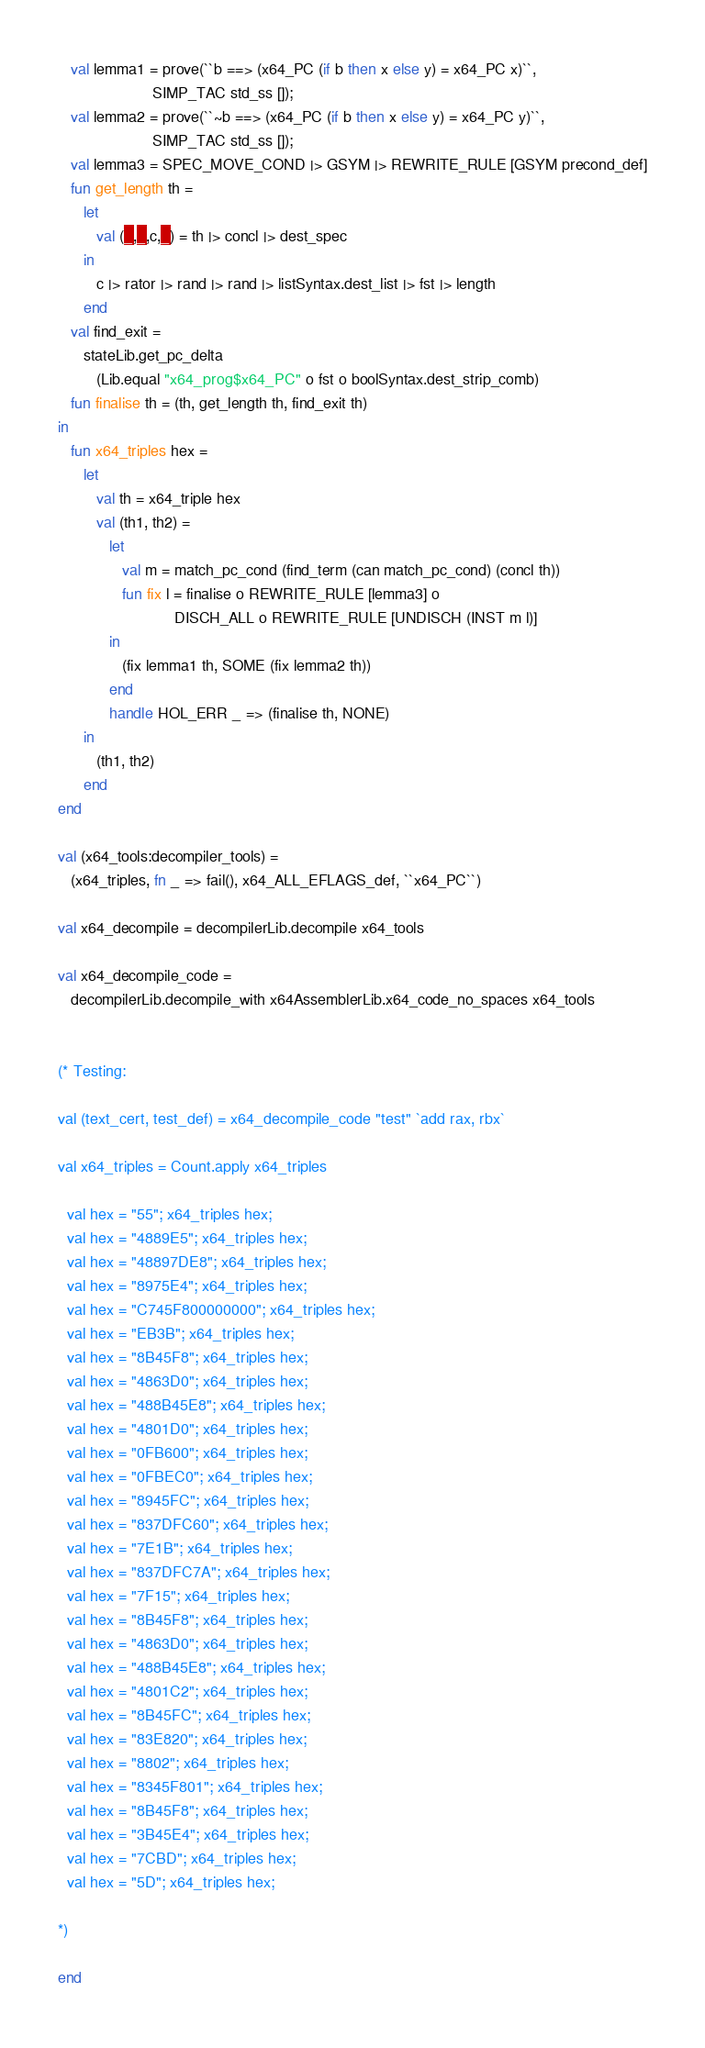Convert code to text. <code><loc_0><loc_0><loc_500><loc_500><_SML_>   val lemma1 = prove(``b ==> (x64_PC (if b then x else y) = x64_PC x)``,
                      SIMP_TAC std_ss []);
   val lemma2 = prove(``~b ==> (x64_PC (if b then x else y) = x64_PC y)``,
                      SIMP_TAC std_ss []);
   val lemma3 = SPEC_MOVE_COND |> GSYM |> REWRITE_RULE [GSYM precond_def]
   fun get_length th =
      let
         val (_,_,c,_) = th |> concl |> dest_spec
      in
         c |> rator |> rand |> rand |> listSyntax.dest_list |> fst |> length
      end
   val find_exit =
      stateLib.get_pc_delta
         (Lib.equal "x64_prog$x64_PC" o fst o boolSyntax.dest_strip_comb)
   fun finalise th = (th, get_length th, find_exit th)
in
   fun x64_triples hex =
      let
         val th = x64_triple hex
         val (th1, th2) =
            let
               val m = match_pc_cond (find_term (can match_pc_cond) (concl th))
               fun fix l = finalise o REWRITE_RULE [lemma3] o
                           DISCH_ALL o REWRITE_RULE [UNDISCH (INST m l)]
            in
               (fix lemma1 th, SOME (fix lemma2 th))
            end
            handle HOL_ERR _ => (finalise th, NONE)
      in
         (th1, th2)
      end
end

val (x64_tools:decompiler_tools) =
   (x64_triples, fn _ => fail(), x64_ALL_EFLAGS_def, ``x64_PC``)

val x64_decompile = decompilerLib.decompile x64_tools

val x64_decompile_code =
   decompilerLib.decompile_with x64AssemblerLib.x64_code_no_spaces x64_tools


(* Testing:

val (text_cert, test_def) = x64_decompile_code "test" `add rax, rbx`

val x64_triples = Count.apply x64_triples

  val hex = "55"; x64_triples hex;
  val hex = "4889E5"; x64_triples hex;
  val hex = "48897DE8"; x64_triples hex;
  val hex = "8975E4"; x64_triples hex;
  val hex = "C745F800000000"; x64_triples hex;
  val hex = "EB3B"; x64_triples hex;
  val hex = "8B45F8"; x64_triples hex;
  val hex = "4863D0"; x64_triples hex;
  val hex = "488B45E8"; x64_triples hex;
  val hex = "4801D0"; x64_triples hex;
  val hex = "0FB600"; x64_triples hex;
  val hex = "0FBEC0"; x64_triples hex;
  val hex = "8945FC"; x64_triples hex;
  val hex = "837DFC60"; x64_triples hex;
  val hex = "7E1B"; x64_triples hex;
  val hex = "837DFC7A"; x64_triples hex;
  val hex = "7F15"; x64_triples hex;
  val hex = "8B45F8"; x64_triples hex;
  val hex = "4863D0"; x64_triples hex;
  val hex = "488B45E8"; x64_triples hex;
  val hex = "4801C2"; x64_triples hex;
  val hex = "8B45FC"; x64_triples hex;
  val hex = "83E820"; x64_triples hex;
  val hex = "8802"; x64_triples hex;
  val hex = "8345F801"; x64_triples hex;
  val hex = "8B45F8"; x64_triples hex;
  val hex = "3B45E4"; x64_triples hex;
  val hex = "7CBD"; x64_triples hex;
  val hex = "5D"; x64_triples hex;

*)

end
</code> 